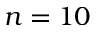Convert formula to latex. <formula><loc_0><loc_0><loc_500><loc_500>n = 1 0</formula> 